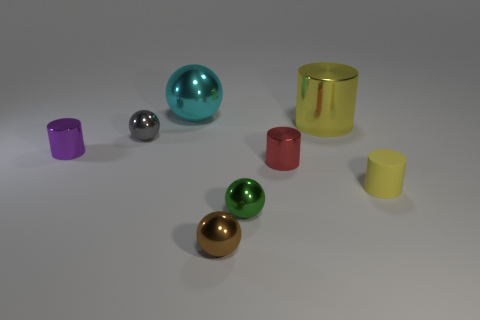Add 2 purple metallic cylinders. How many objects exist? 10 Add 5 tiny purple objects. How many tiny purple objects are left? 6 Add 5 small cyan cylinders. How many small cyan cylinders exist? 5 Subtract 0 red spheres. How many objects are left? 8 Subtract all yellow matte cylinders. Subtract all tiny red cylinders. How many objects are left? 6 